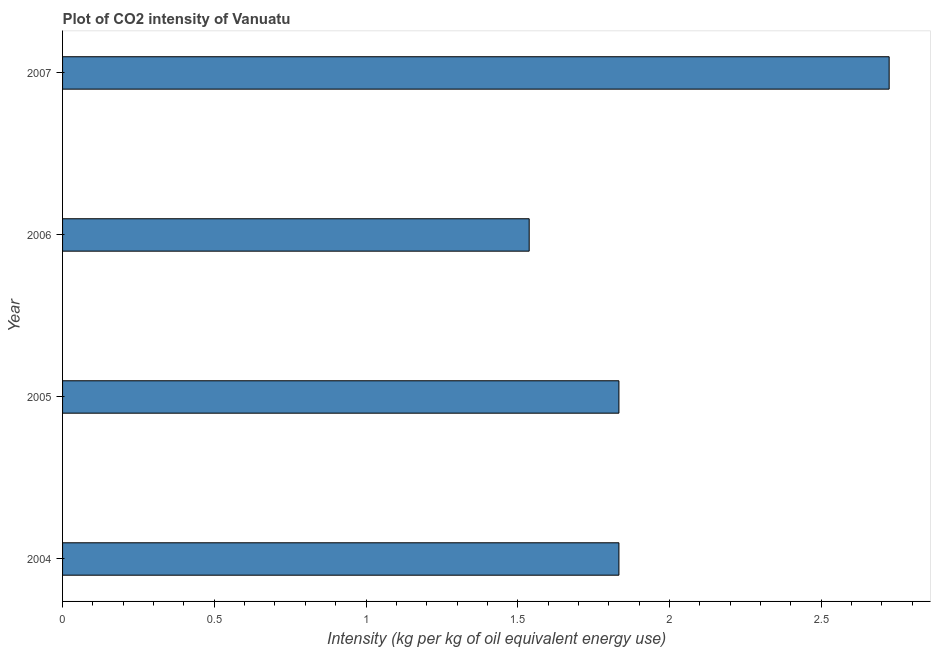Does the graph contain grids?
Your response must be concise. No. What is the title of the graph?
Offer a very short reply. Plot of CO2 intensity of Vanuatu. What is the label or title of the X-axis?
Your response must be concise. Intensity (kg per kg of oil equivalent energy use). What is the label or title of the Y-axis?
Provide a succinct answer. Year. What is the co2 intensity in 2007?
Keep it short and to the point. 2.72. Across all years, what is the maximum co2 intensity?
Your answer should be very brief. 2.72. Across all years, what is the minimum co2 intensity?
Give a very brief answer. 1.54. What is the sum of the co2 intensity?
Provide a short and direct response. 7.93. What is the difference between the co2 intensity in 2005 and 2006?
Give a very brief answer. 0.3. What is the average co2 intensity per year?
Ensure brevity in your answer.  1.98. What is the median co2 intensity?
Your response must be concise. 1.83. Is the co2 intensity in 2004 less than that in 2006?
Offer a terse response. No. What is the difference between the highest and the second highest co2 intensity?
Your answer should be compact. 0.89. What is the difference between the highest and the lowest co2 intensity?
Your answer should be compact. 1.19. Are all the bars in the graph horizontal?
Your answer should be very brief. Yes. What is the difference between two consecutive major ticks on the X-axis?
Provide a short and direct response. 0.5. What is the Intensity (kg per kg of oil equivalent energy use) in 2004?
Provide a short and direct response. 1.83. What is the Intensity (kg per kg of oil equivalent energy use) in 2005?
Your answer should be compact. 1.83. What is the Intensity (kg per kg of oil equivalent energy use) of 2006?
Provide a succinct answer. 1.54. What is the Intensity (kg per kg of oil equivalent energy use) in 2007?
Keep it short and to the point. 2.72. What is the difference between the Intensity (kg per kg of oil equivalent energy use) in 2004 and 2006?
Your answer should be very brief. 0.3. What is the difference between the Intensity (kg per kg of oil equivalent energy use) in 2004 and 2007?
Ensure brevity in your answer.  -0.89. What is the difference between the Intensity (kg per kg of oil equivalent energy use) in 2005 and 2006?
Make the answer very short. 0.3. What is the difference between the Intensity (kg per kg of oil equivalent energy use) in 2005 and 2007?
Provide a short and direct response. -0.89. What is the difference between the Intensity (kg per kg of oil equivalent energy use) in 2006 and 2007?
Ensure brevity in your answer.  -1.19. What is the ratio of the Intensity (kg per kg of oil equivalent energy use) in 2004 to that in 2006?
Your response must be concise. 1.19. What is the ratio of the Intensity (kg per kg of oil equivalent energy use) in 2004 to that in 2007?
Make the answer very short. 0.67. What is the ratio of the Intensity (kg per kg of oil equivalent energy use) in 2005 to that in 2006?
Your answer should be very brief. 1.19. What is the ratio of the Intensity (kg per kg of oil equivalent energy use) in 2005 to that in 2007?
Keep it short and to the point. 0.67. What is the ratio of the Intensity (kg per kg of oil equivalent energy use) in 2006 to that in 2007?
Keep it short and to the point. 0.56. 